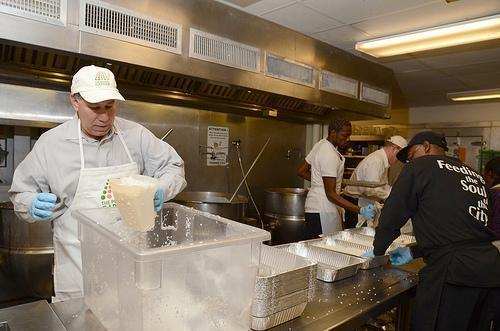How many people are wearing white hats?
Give a very brief answer. 2. 